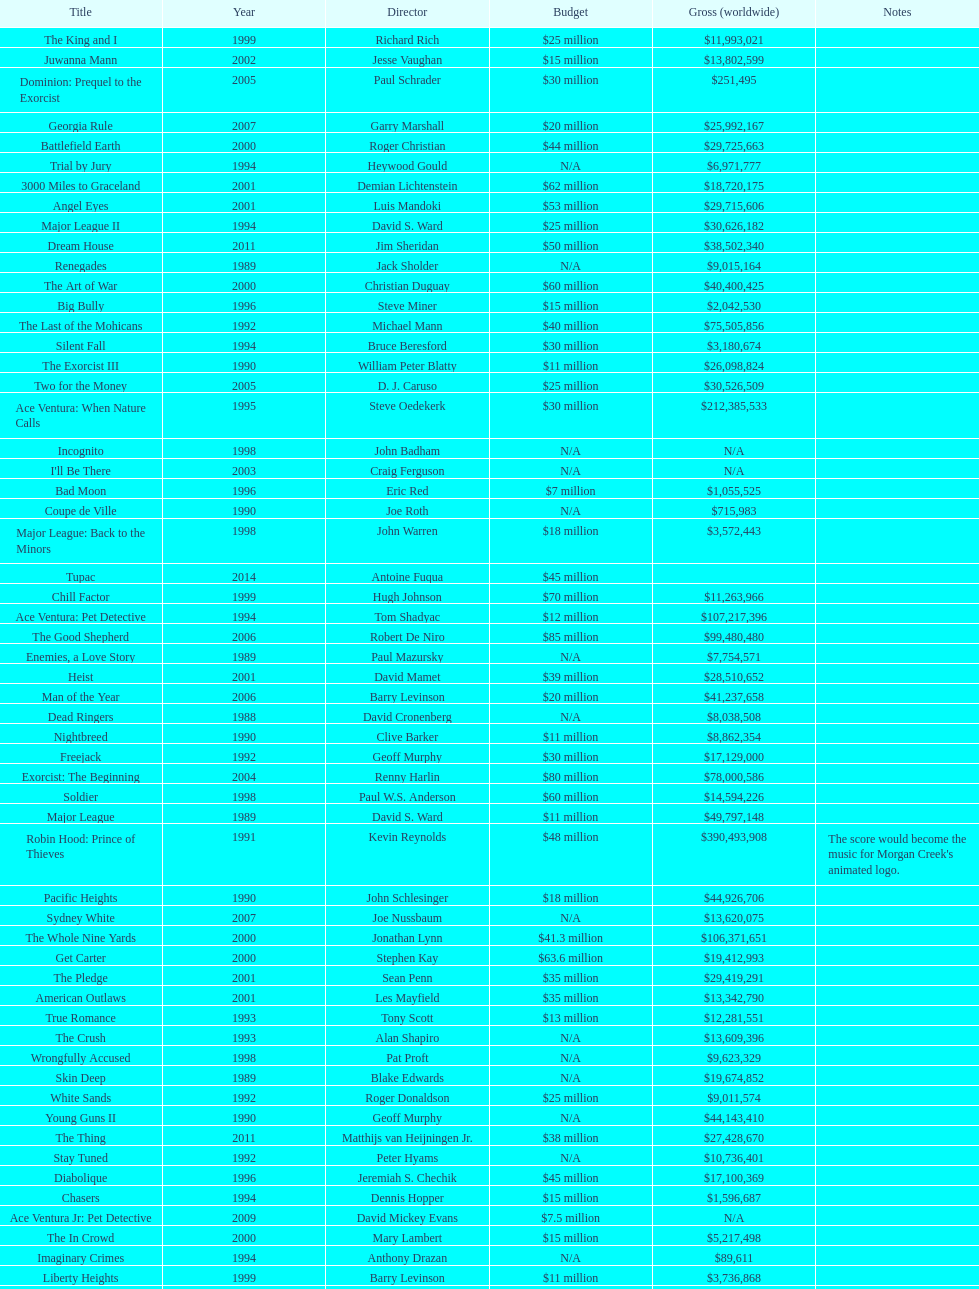Which film had a higher budget, ace ventura: when nature calls, or major league: back to the minors? Ace Ventura: When Nature Calls. Would you be able to parse every entry in this table? {'header': ['Title', 'Year', 'Director', 'Budget', 'Gross (worldwide)', 'Notes'], 'rows': [['The King and I', '1999', 'Richard Rich', '$25 million', '$11,993,021', ''], ['Juwanna Mann', '2002', 'Jesse Vaughan', '$15 million', '$13,802,599', ''], ['Dominion: Prequel to the Exorcist', '2005', 'Paul Schrader', '$30 million', '$251,495', ''], ['Georgia Rule', '2007', 'Garry Marshall', '$20 million', '$25,992,167', ''], ['Battlefield Earth', '2000', 'Roger Christian', '$44 million', '$29,725,663', ''], ['Trial by Jury', '1994', 'Heywood Gould', 'N/A', '$6,971,777', ''], ['3000 Miles to Graceland', '2001', 'Demian Lichtenstein', '$62 million', '$18,720,175', ''], ['Angel Eyes', '2001', 'Luis Mandoki', '$53 million', '$29,715,606', ''], ['Major League II', '1994', 'David S. Ward', '$25 million', '$30,626,182', ''], ['Dream House', '2011', 'Jim Sheridan', '$50 million', '$38,502,340', ''], ['Renegades', '1989', 'Jack Sholder', 'N/A', '$9,015,164', ''], ['The Art of War', '2000', 'Christian Duguay', '$60 million', '$40,400,425', ''], ['Big Bully', '1996', 'Steve Miner', '$15 million', '$2,042,530', ''], ['The Last of the Mohicans', '1992', 'Michael Mann', '$40 million', '$75,505,856', ''], ['Silent Fall', '1994', 'Bruce Beresford', '$30 million', '$3,180,674', ''], ['The Exorcist III', '1990', 'William Peter Blatty', '$11 million', '$26,098,824', ''], ['Two for the Money', '2005', 'D. J. Caruso', '$25 million', '$30,526,509', ''], ['Ace Ventura: When Nature Calls', '1995', 'Steve Oedekerk', '$30 million', '$212,385,533', ''], ['Incognito', '1998', 'John Badham', 'N/A', 'N/A', ''], ["I'll Be There", '2003', 'Craig Ferguson', 'N/A', 'N/A', ''], ['Bad Moon', '1996', 'Eric Red', '$7 million', '$1,055,525', ''], ['Coupe de Ville', '1990', 'Joe Roth', 'N/A', '$715,983', ''], ['Major League: Back to the Minors', '1998', 'John Warren', '$18 million', '$3,572,443', ''], ['Tupac', '2014', 'Antoine Fuqua', '$45 million', '', ''], ['Chill Factor', '1999', 'Hugh Johnson', '$70 million', '$11,263,966', ''], ['Ace Ventura: Pet Detective', '1994', 'Tom Shadyac', '$12 million', '$107,217,396', ''], ['The Good Shepherd', '2006', 'Robert De Niro', '$85 million', '$99,480,480', ''], ['Enemies, a Love Story', '1989', 'Paul Mazursky', 'N/A', '$7,754,571', ''], ['Heist', '2001', 'David Mamet', '$39 million', '$28,510,652', ''], ['Man of the Year', '2006', 'Barry Levinson', '$20 million', '$41,237,658', ''], ['Dead Ringers', '1988', 'David Cronenberg', 'N/A', '$8,038,508', ''], ['Nightbreed', '1990', 'Clive Barker', '$11 million', '$8,862,354', ''], ['Freejack', '1992', 'Geoff Murphy', '$30 million', '$17,129,000', ''], ['Exorcist: The Beginning', '2004', 'Renny Harlin', '$80 million', '$78,000,586', ''], ['Soldier', '1998', 'Paul W.S. Anderson', '$60 million', '$14,594,226', ''], ['Major League', '1989', 'David S. Ward', '$11 million', '$49,797,148', ''], ['Robin Hood: Prince of Thieves', '1991', 'Kevin Reynolds', '$48 million', '$390,493,908', "The score would become the music for Morgan Creek's animated logo."], ['Pacific Heights', '1990', 'John Schlesinger', '$18 million', '$44,926,706', ''], ['Sydney White', '2007', 'Joe Nussbaum', 'N/A', '$13,620,075', ''], ['The Whole Nine Yards', '2000', 'Jonathan Lynn', '$41.3 million', '$106,371,651', ''], ['Get Carter', '2000', 'Stephen Kay', '$63.6 million', '$19,412,993', ''], ['The Pledge', '2001', 'Sean Penn', '$35 million', '$29,419,291', ''], ['American Outlaws', '2001', 'Les Mayfield', '$35 million', '$13,342,790', ''], ['True Romance', '1993', 'Tony Scott', '$13 million', '$12,281,551', ''], ['The Crush', '1993', 'Alan Shapiro', 'N/A', '$13,609,396', ''], ['Wrongfully Accused', '1998', 'Pat Proft', 'N/A', '$9,623,329', ''], ['Skin Deep', '1989', 'Blake Edwards', 'N/A', '$19,674,852', ''], ['White Sands', '1992', 'Roger Donaldson', '$25 million', '$9,011,574', ''], ['Young Guns II', '1990', 'Geoff Murphy', 'N/A', '$44,143,410', ''], ['The Thing', '2011', 'Matthijs van Heijningen Jr.', '$38 million', '$27,428,670', ''], ['Stay Tuned', '1992', 'Peter Hyams', 'N/A', '$10,736,401', ''], ['Diabolique', '1996', 'Jeremiah S. Chechik', '$45 million', '$17,100,369', ''], ['Chasers', '1994', 'Dennis Hopper', '$15 million', '$1,596,687', ''], ['Ace Ventura Jr: Pet Detective', '2009', 'David Mickey Evans', '$7.5 million', 'N/A', ''], ['The In Crowd', '2000', 'Mary Lambert', '$15 million', '$5,217,498', ''], ['Imaginary Crimes', '1994', 'Anthony Drazan', 'N/A', '$89,611', ''], ['Liberty Heights', '1999', 'Barry Levinson', '$11 million', '$3,736,868', ''], ['Two If by Sea', '1996', 'Bill Bennett', 'N/A', '$10,658,278', ''], ['Wild America', '1997', 'William Dear', 'N/A', '$7,324,662', ''], ['Young Guns', '1988', 'Christopher Cain', '$11 million', '$45,661,556', '']]} 